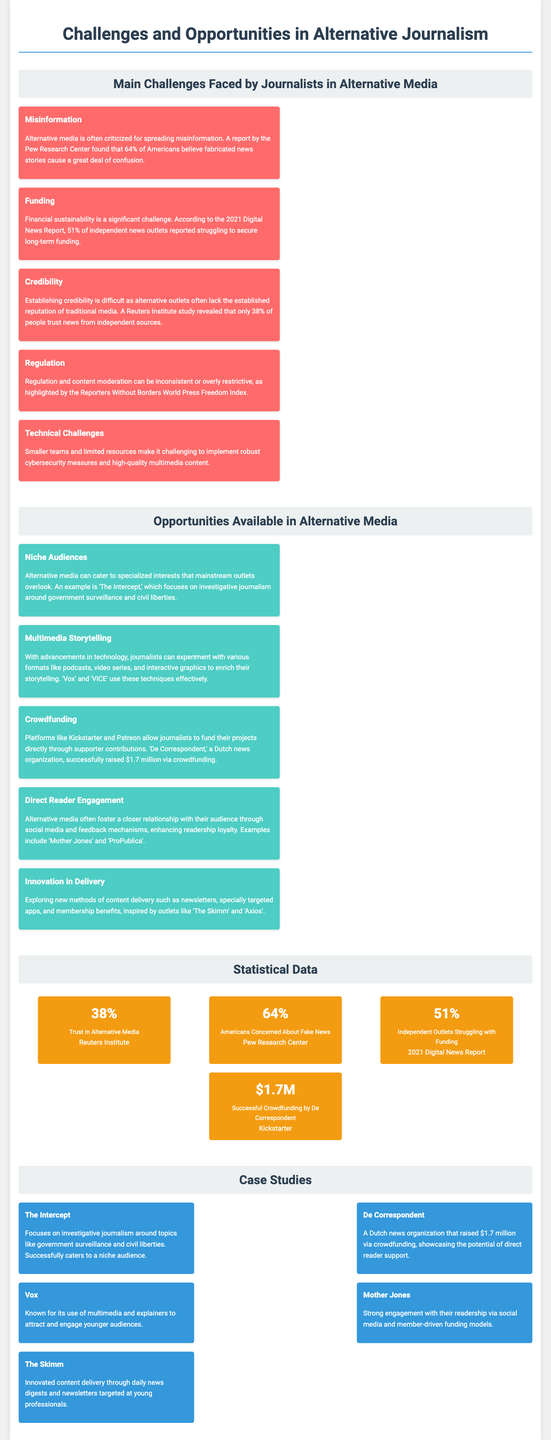What percentage of people trust news from independent sources? The document states that only 38% of people trust news from independent sources as revealed by a Reuters Institute study.
Answer: 38% What is a significant challenge related to funding faced by independent news outlets? According to the 2021 Digital News Report, 51% of independent news outlets reported struggling to secure long-term funding.
Answer: 51% What example of alternative media focuses on investigative journalism around government surveillance? The example given in the document is 'The Intercept,' which focuses on investigative journalism around government surveillance and civil liberties.
Answer: The Intercept How much money did De Correspondent raise via crowdfunding? The document mentions that De Correspondent successfully raised $1.7 million via crowdfunding through platforms like Kickstarter.
Answer: $1.7 million What is the main risk associated with misinformation in alternative media? The document notes that a report by the Pew Research Center found that 64% of Americans believe fabricated news stories cause a great deal of confusion.
Answer: 64% Which organization is known for innovative content delivery through daily news digests targeted at young professionals? The document states that 'The Skimm' is recognized for innovating content delivery through daily news digests and newsletters targeted at young professionals.
Answer: The Skimm What technological method is mentioned for enhancing storytelling in alternative media? The document discusses multimedia storytelling as a method that journalists can experiment with, including formats like podcasts and video series.
Answer: Multimedia storytelling Which outlet successfully fosters a closer relationship with their audience through social media? The document lists 'Mother Jones' as an example of an outlet that fosters closer audience relationships through social media and feedback mechanisms.
Answer: Mother Jones 